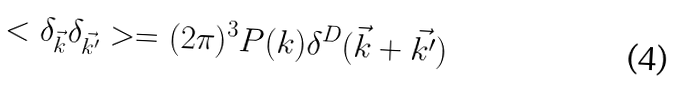Convert formula to latex. <formula><loc_0><loc_0><loc_500><loc_500>< \delta _ { \vec { k } } \delta _ { \vec { k ^ { \prime } } } > = ( 2 \pi ) ^ { 3 } P ( k ) \delta ^ { D } ( \vec { k } + \vec { k ^ { \prime } } )</formula> 